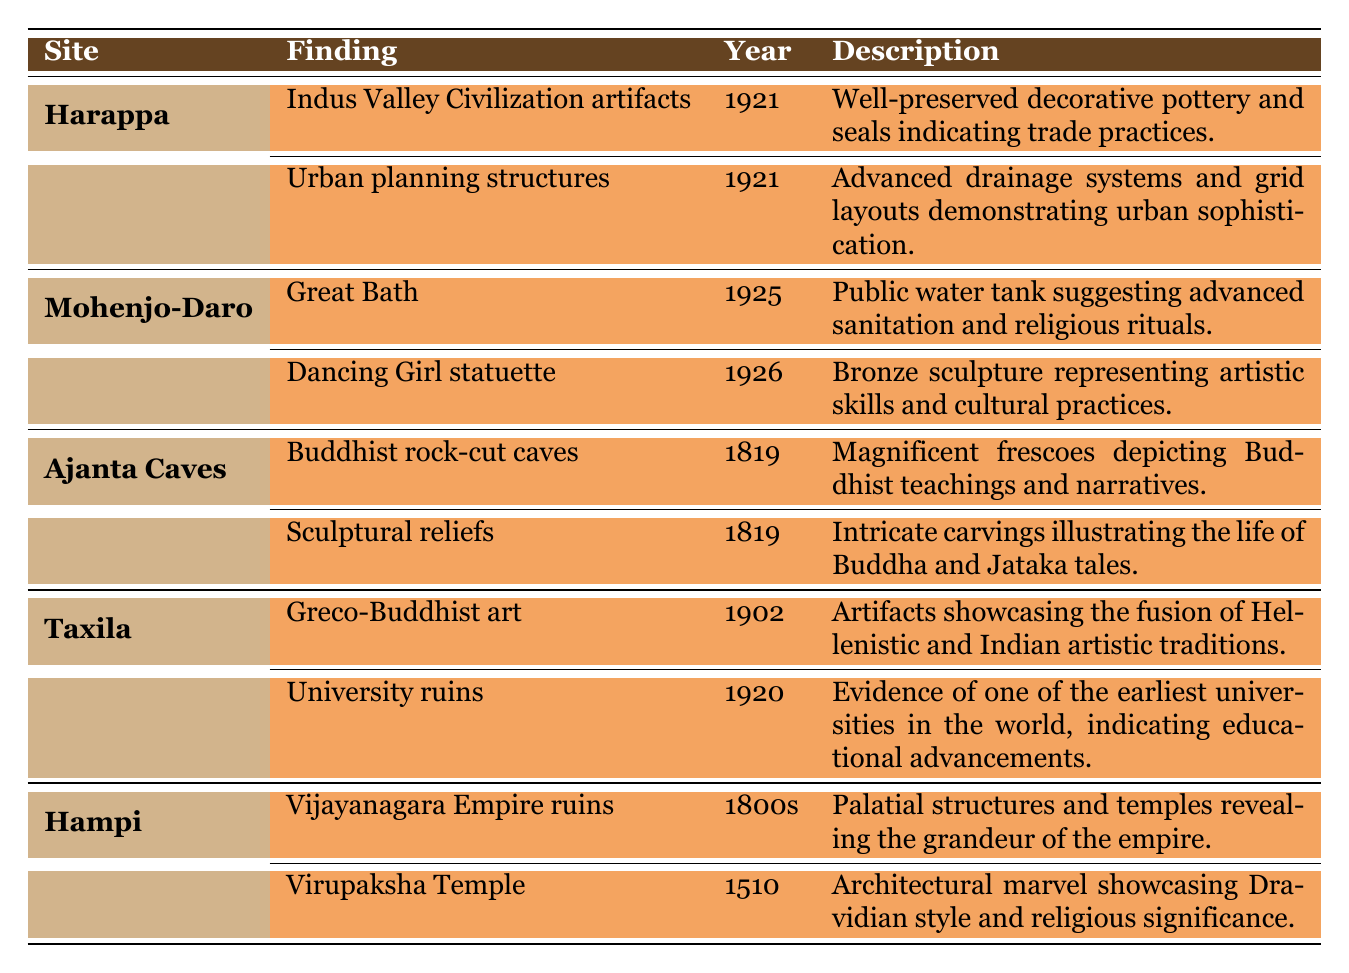What significant finding was made at Harappa in 1921? The table shows that two significant findings were made at Harappa in 1921: "Indus Valley Civilization artifacts" and "Urban planning structures."
Answer: Indus Valley Civilization artifacts Which archaeological site is associated with the "Dancing Girl statuette"? According to the table, the "Dancing Girl statuette" is a significant finding at Mohenjo-Daro.
Answer: Mohenjo-Daro How many total significant findings are listed for the Ajanta Caves? The table indicates that there are two significant findings listed for the Ajanta Caves: "Buddhist rock-cut caves" and "Sculptural reliefs."
Answer: 2 Which site has a finding that indicates advanced sanitation practices? The finding "Great Bath" at Mohenjo-Daro indicates advanced sanitation practices, as described in the table.
Answer: Mohenjo-Daro Is there evidence of a university at Taxila according to the table? Yes, the table lists "University ruins" as a significant finding at Taxila, indicating evidence of an early university.
Answer: Yes What year did the findings for the Hampi site begin? The findings for Hampi begin in the 1800s, as noted in the table under the finding "Vijayanagara Empire ruins."
Answer: 1800s Which site includes findings that illustrate Buddhist teachings and narratives? The Ajanta Caves are associated with findings that illustrate Buddhist teachings, specifically "Buddhist rock-cut caves" and "Sculptural reliefs."
Answer: Ajanta Caves What year was the finding of Greco-Buddhist art at Taxila discovered? The table states that the finding of "Greco-Buddhist art" at Taxila was discovered in 1902.
Answer: 1902 Which finding indicates the architectural style of the Vijayanagara Empire? The "Virupaksha Temple" finding at Hampi showcases the Dravidian architectural style of the Vijayanagara Empire.
Answer: Virupaksha Temple 